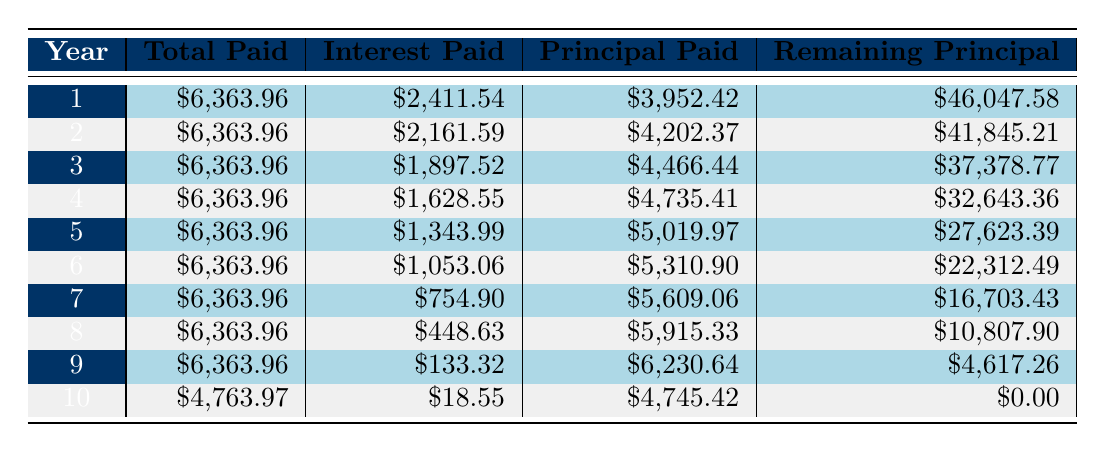What is the total amount paid in the first year? Looking at the table, the total amount paid in Year 1 is specifically stated as $6,363.96.
Answer: $6,363.96 How much was the interest paid in year 5? Referring to the table, the interest paid in Year 5 is directly listed as $1,343.99.
Answer: $1,343.99 What is the remaining principal after three years? The table shows the remaining principal after Year 3 as $37,378.77.
Answer: $37,378.77 What was the average principal paid per year over the loan term? To find the average principal paid, we sum the principal paid each year: 3952.42 + 4202.37 + 4466.44 + 4735.41 + 5019.97 + 5310.90 + 5609.06 + 5915.33 + 6230.64 + 4745.42 = 50,045.46. There are 10 years, so the average is 50,045.46 / 10 = 5,004.55.
Answer: $5,004.55 Did the interest paid decrease every year? By examining the interest paid each year in the table, it shows a decrease from Year 1 ($2,411.54) to Year 10 ($18.55). This illustrates a clear trend of decreasing interest payments each year.
Answer: Yes In which year was the highest principal paid? By reviewing the table, the highest principal paid is noted in Year 5 where it amounts to $5,019.97.
Answer: Year 5 What is the total amount paid over the entire loan term? The total paid is calculated by summing the 'Total Paid' over the 10 years: $6,363.96 (Year 1) + $6,363.96 (Year 2) + $6,363.96 (Year 3) + $6,363.96 (Year 4) + $6,363.96 (Year 5) + $6,363.96 (Year 6) + $6,363.96 (Year 7) + $6,363.96 (Year 8) + $6,363.96 (Year 9) + $4,763.97 (Year 10) = $63,638.84.
Answer: $63,638.84 What was the total interest accrued after the first four years? To calculate the total interest accrued after four years, we sum the interest paid: $2,411.54 + $2,161.59 + $1,897.52 + $1,628.55 = $8,099.20.
Answer: $8,099.20 How much less was the interest paid in the last year compared to the first year? The interest paid in Year 1 was $2,411.54 and in Year 10 it was $18.55. The difference is $2,411.54 - $18.55 = $2,392.99.
Answer: $2,392.99 